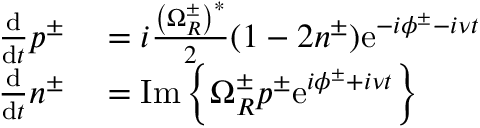Convert formula to latex. <formula><loc_0><loc_0><loc_500><loc_500>\begin{array} { r l } { \frac { d } { d t } p ^ { \pm } } & = i \frac { \left ( \Omega _ { R } ^ { \pm } \right ) ^ { * } } { 2 } ( 1 - 2 n ^ { \pm } ) e ^ { - i \phi ^ { \pm } - i \nu t } } \\ { \frac { d } { d t } n ^ { \pm } } & = I m \left \{ \Omega _ { R } ^ { \pm } p ^ { \pm } e ^ { i \phi ^ { \pm } + i \nu t } \right \} } \end{array}</formula> 